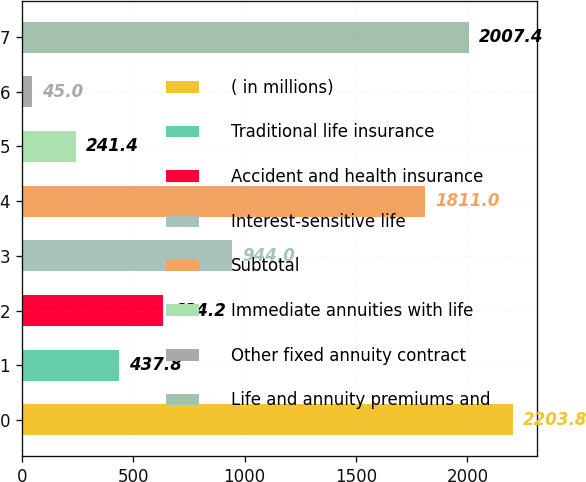Convert chart to OTSL. <chart><loc_0><loc_0><loc_500><loc_500><bar_chart><fcel>( in millions)<fcel>Traditional life insurance<fcel>Accident and health insurance<fcel>Interest-sensitive life<fcel>Subtotal<fcel>Immediate annuities with life<fcel>Other fixed annuity contract<fcel>Life and annuity premiums and<nl><fcel>2203.8<fcel>437.8<fcel>634.2<fcel>944<fcel>1811<fcel>241.4<fcel>45<fcel>2007.4<nl></chart> 